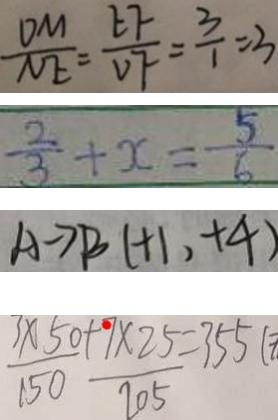Convert formula to latex. <formula><loc_0><loc_0><loc_500><loc_500>\frac { D M } { N E } = \frac { E F } { v F } = \frac { 3 } { 1 } = 3 
 \frac { 2 } { 3 } + x = \frac { 5 } { 6 } 
 A \rightarrow B ( + 1 , + 4 ) 
 \frac { 3 \times 5 0 } { 1 5 0 } + \frac { 9 \times 2 5 } { 2 0 5 } = 3 5 5 (</formula> 